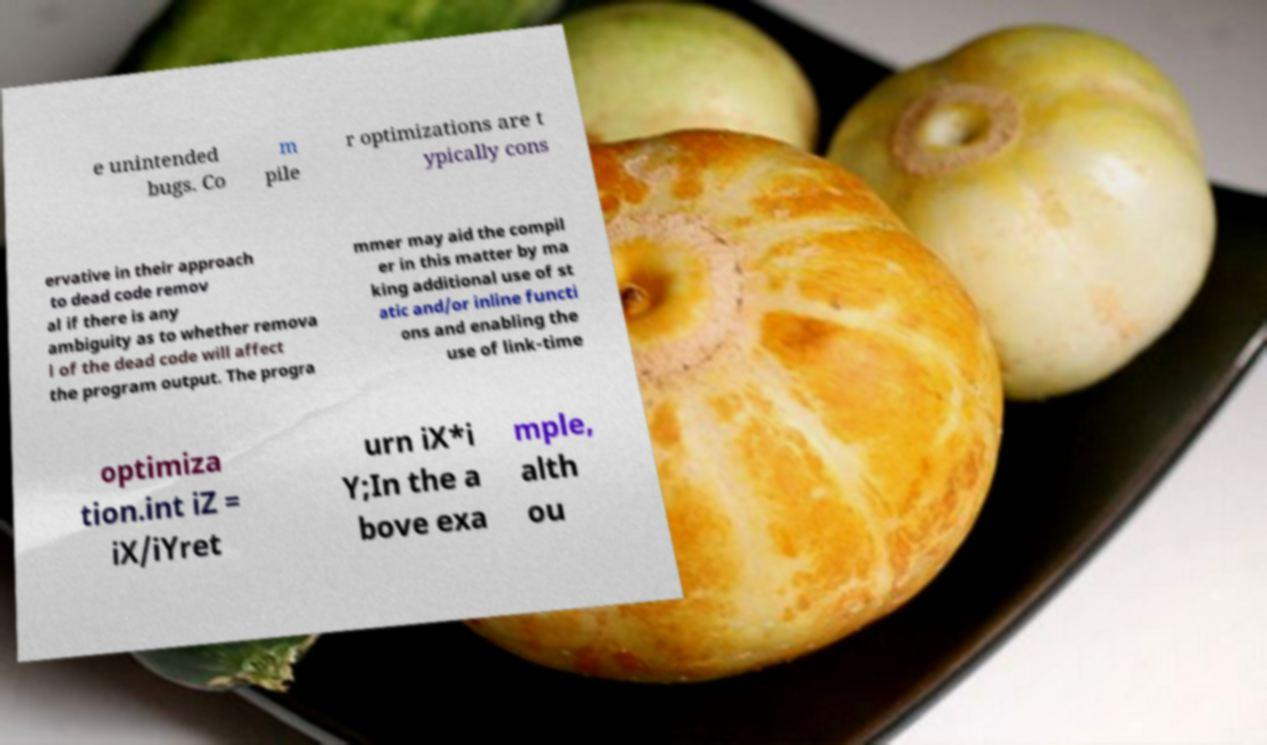What messages or text are displayed in this image? I need them in a readable, typed format. e unintended bugs. Co m pile r optimizations are t ypically cons ervative in their approach to dead code remov al if there is any ambiguity as to whether remova l of the dead code will affect the program output. The progra mmer may aid the compil er in this matter by ma king additional use of st atic and/or inline functi ons and enabling the use of link-time optimiza tion.int iZ = iX/iYret urn iX*i Y;In the a bove exa mple, alth ou 